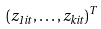Convert formula to latex. <formula><loc_0><loc_0><loc_500><loc_500>( z _ { 1 i t } , \dots , z _ { k i t } ) ^ { T }</formula> 